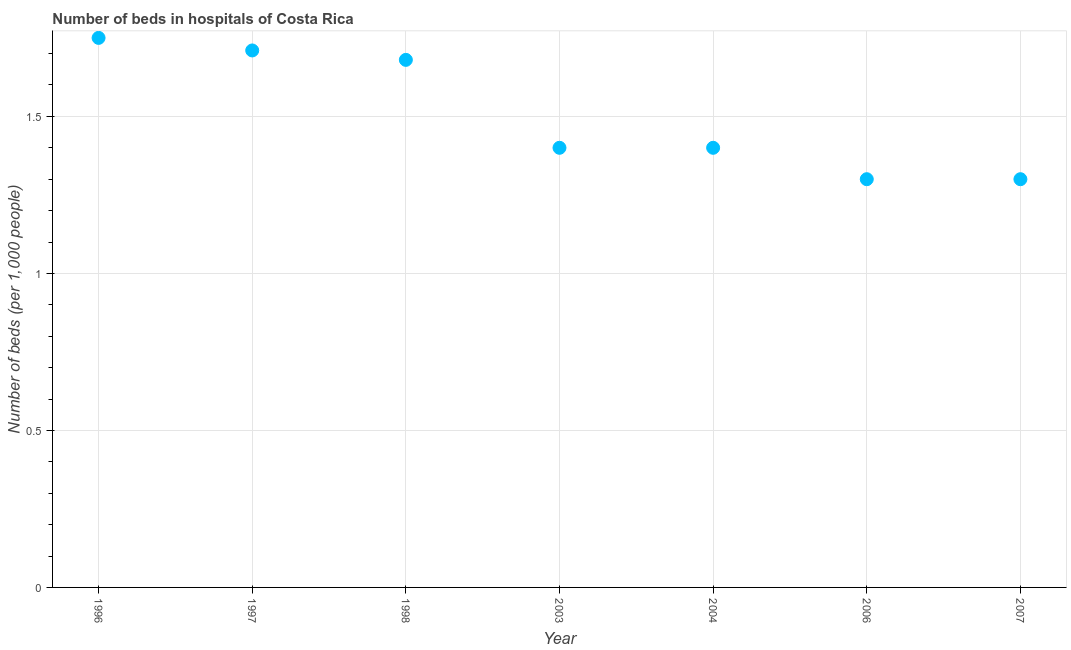In which year was the number of hospital beds maximum?
Ensure brevity in your answer.  1996. In which year was the number of hospital beds minimum?
Give a very brief answer. 2006. What is the sum of the number of hospital beds?
Your answer should be compact. 10.54. What is the difference between the number of hospital beds in 1997 and 2006?
Offer a very short reply. 0.41. What is the average number of hospital beds per year?
Your answer should be compact. 1.51. In how many years, is the number of hospital beds greater than 1.3 %?
Offer a very short reply. 5. What is the ratio of the number of hospital beds in 2003 to that in 2004?
Offer a terse response. 1. What is the difference between the highest and the second highest number of hospital beds?
Your answer should be very brief. 0.04. What is the difference between the highest and the lowest number of hospital beds?
Make the answer very short. 0.45. In how many years, is the number of hospital beds greater than the average number of hospital beds taken over all years?
Ensure brevity in your answer.  3. Does the number of hospital beds monotonically increase over the years?
Provide a short and direct response. No. How many dotlines are there?
Your answer should be compact. 1. How many years are there in the graph?
Give a very brief answer. 7. What is the title of the graph?
Your answer should be compact. Number of beds in hospitals of Costa Rica. What is the label or title of the Y-axis?
Make the answer very short. Number of beds (per 1,0 people). What is the Number of beds (per 1,000 people) in 1997?
Offer a terse response. 1.71. What is the Number of beds (per 1,000 people) in 1998?
Your answer should be compact. 1.68. What is the Number of beds (per 1,000 people) in 2003?
Offer a very short reply. 1.4. What is the Number of beds (per 1,000 people) in 2004?
Ensure brevity in your answer.  1.4. What is the Number of beds (per 1,000 people) in 2006?
Provide a succinct answer. 1.3. What is the Number of beds (per 1,000 people) in 2007?
Make the answer very short. 1.3. What is the difference between the Number of beds (per 1,000 people) in 1996 and 1997?
Offer a terse response. 0.04. What is the difference between the Number of beds (per 1,000 people) in 1996 and 1998?
Your answer should be compact. 0.07. What is the difference between the Number of beds (per 1,000 people) in 1996 and 2006?
Keep it short and to the point. 0.45. What is the difference between the Number of beds (per 1,000 people) in 1996 and 2007?
Make the answer very short. 0.45. What is the difference between the Number of beds (per 1,000 people) in 1997 and 2003?
Offer a very short reply. 0.31. What is the difference between the Number of beds (per 1,000 people) in 1997 and 2004?
Provide a succinct answer. 0.31. What is the difference between the Number of beds (per 1,000 people) in 1997 and 2006?
Provide a short and direct response. 0.41. What is the difference between the Number of beds (per 1,000 people) in 1997 and 2007?
Offer a very short reply. 0.41. What is the difference between the Number of beds (per 1,000 people) in 1998 and 2003?
Make the answer very short. 0.28. What is the difference between the Number of beds (per 1,000 people) in 1998 and 2004?
Your response must be concise. 0.28. What is the difference between the Number of beds (per 1,000 people) in 1998 and 2006?
Provide a succinct answer. 0.38. What is the difference between the Number of beds (per 1,000 people) in 1998 and 2007?
Your response must be concise. 0.38. What is the difference between the Number of beds (per 1,000 people) in 2003 and 2006?
Make the answer very short. 0.1. What is the difference between the Number of beds (per 1,000 people) in 2004 and 2006?
Your answer should be compact. 0.1. What is the difference between the Number of beds (per 1,000 people) in 2004 and 2007?
Your response must be concise. 0.1. What is the ratio of the Number of beds (per 1,000 people) in 1996 to that in 1998?
Your answer should be very brief. 1.04. What is the ratio of the Number of beds (per 1,000 people) in 1996 to that in 2003?
Your answer should be compact. 1.25. What is the ratio of the Number of beds (per 1,000 people) in 1996 to that in 2004?
Offer a terse response. 1.25. What is the ratio of the Number of beds (per 1,000 people) in 1996 to that in 2006?
Make the answer very short. 1.35. What is the ratio of the Number of beds (per 1,000 people) in 1996 to that in 2007?
Your answer should be very brief. 1.35. What is the ratio of the Number of beds (per 1,000 people) in 1997 to that in 2003?
Your response must be concise. 1.22. What is the ratio of the Number of beds (per 1,000 people) in 1997 to that in 2004?
Keep it short and to the point. 1.22. What is the ratio of the Number of beds (per 1,000 people) in 1997 to that in 2006?
Offer a very short reply. 1.31. What is the ratio of the Number of beds (per 1,000 people) in 1997 to that in 2007?
Give a very brief answer. 1.31. What is the ratio of the Number of beds (per 1,000 people) in 1998 to that in 2003?
Give a very brief answer. 1.2. What is the ratio of the Number of beds (per 1,000 people) in 1998 to that in 2006?
Offer a very short reply. 1.29. What is the ratio of the Number of beds (per 1,000 people) in 1998 to that in 2007?
Keep it short and to the point. 1.29. What is the ratio of the Number of beds (per 1,000 people) in 2003 to that in 2006?
Your answer should be very brief. 1.08. What is the ratio of the Number of beds (per 1,000 people) in 2003 to that in 2007?
Provide a short and direct response. 1.08. What is the ratio of the Number of beds (per 1,000 people) in 2004 to that in 2006?
Make the answer very short. 1.08. What is the ratio of the Number of beds (per 1,000 people) in 2004 to that in 2007?
Provide a short and direct response. 1.08. 